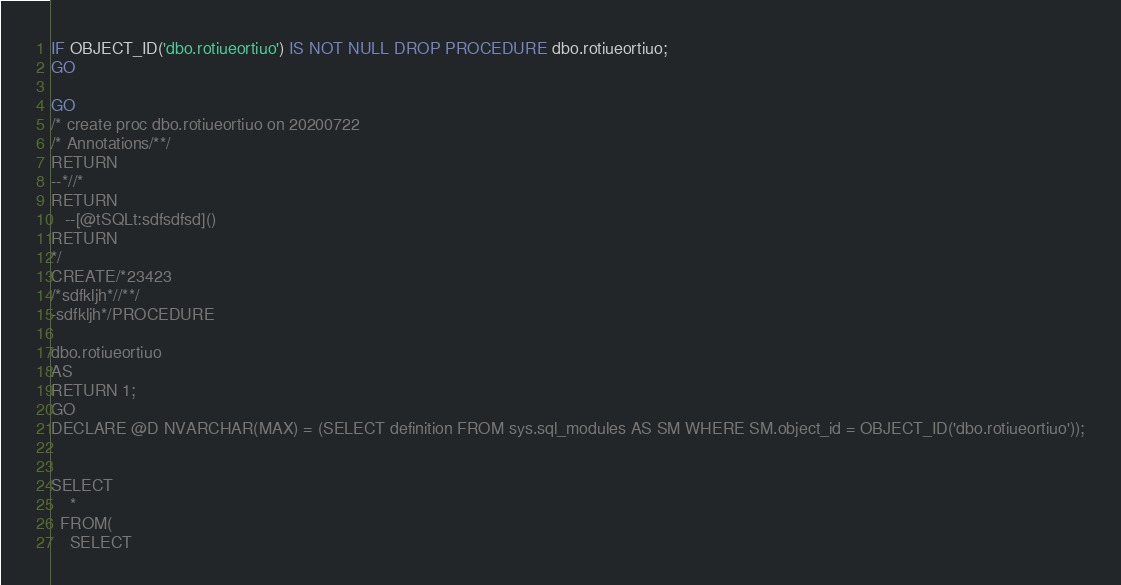Convert code to text. <code><loc_0><loc_0><loc_500><loc_500><_SQL_>IF OBJECT_ID('dbo.rotiueortiuo') IS NOT NULL DROP PROCEDURE dbo.rotiueortiuo;
GO

GO
/* create proc dbo.rotiueortiuo on 20200722
/* Annotations/**/
RETURN
--*//*
RETURN
   --[@tSQLt:sdfsdfsd]()
RETURN
*/
CREATE/*23423
/*sdfkljh*//**/
-sdfkljh*/PROCEDURE 

dbo.rotiueortiuo
AS
RETURN 1;
GO
DECLARE @D NVARCHAR(MAX) = (SELECT definition FROM sys.sql_modules AS SM WHERE SM.object_id = OBJECT_ID('dbo.rotiueortiuo'));


SELECT
    *
  FROM(
    SELECT</code> 